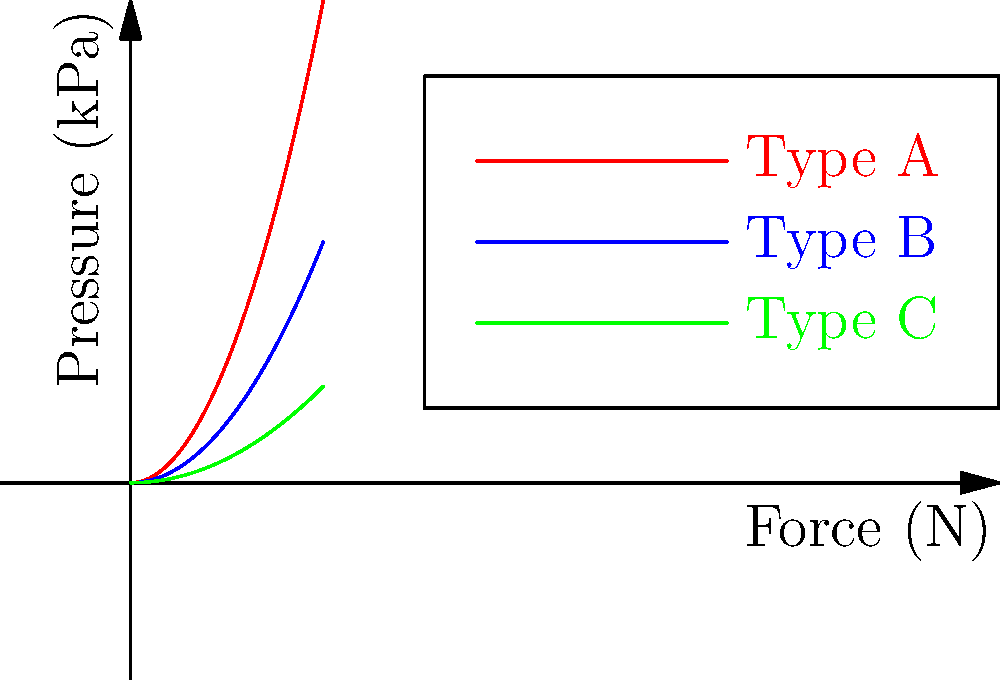As an entrepreneur in the beauty industry, you're evaluating different types of microneedle patches for a new product line. The graph shows the relationship between force and pressure for three types of patches (A, B, and C). Which type of patch would you choose for a gentle, low-pressure application, and what is the approximate pressure applied when a force of 3N is used? To answer this question, we need to analyze the graph and follow these steps:

1. Observe that the graph shows three curves representing different types of microneedle patches (A, B, and C).

2. For a gentle, low-pressure application, we want the patch that applies the least pressure for a given force.

3. Looking at the curves, we can see that:
   - Type A (red) has the steepest curve, indicating it applies the highest pressure for a given force.
   - Type B (blue) has a moderate curve.
   - Type C (green) has the shallowest curve, indicating it applies the least pressure for a given force.

4. Therefore, Type C would be the best choice for a gentle, low-pressure application.

5. To find the approximate pressure applied when a force of 3N is used:
   - Locate the point on the green curve (Type C) that corresponds to a force of 3N on the x-axis.
   - Read the corresponding pressure value on the y-axis.

6. From the graph, we can estimate that when a force of 3N is applied, the pressure for Type C is approximately 0.9 kPa.

This analysis shows that Type C microneedle patches would be the most suitable for gentle application in beauty products, applying a pressure of about 0.9 kPa at 3N of force.
Answer: Type C, 0.9 kPa 